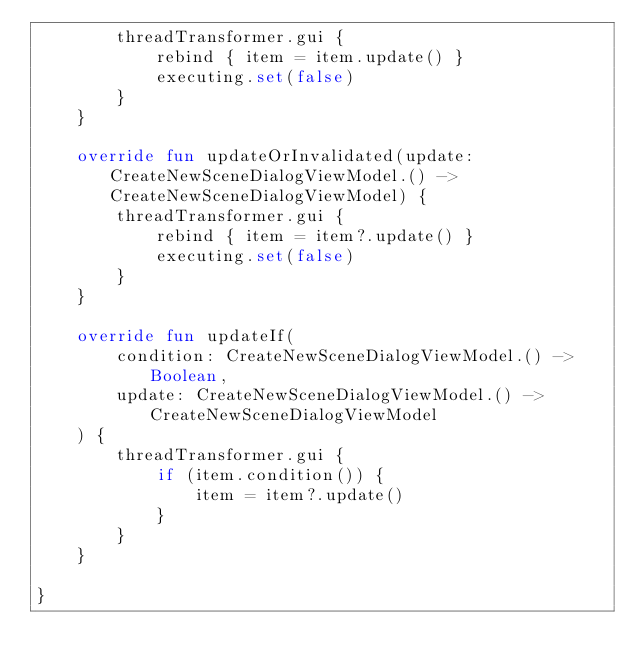<code> <loc_0><loc_0><loc_500><loc_500><_Kotlin_>		threadTransformer.gui {
			rebind { item = item.update() }
			executing.set(false)
		}
	}

	override fun updateOrInvalidated(update: CreateNewSceneDialogViewModel.() -> CreateNewSceneDialogViewModel) {
		threadTransformer.gui {
			rebind { item = item?.update() }
			executing.set(false)
		}
	}

	override fun updateIf(
		condition: CreateNewSceneDialogViewModel.() -> Boolean,
		update: CreateNewSceneDialogViewModel.() -> CreateNewSceneDialogViewModel
	) {
		threadTransformer.gui {
			if (item.condition()) {
				item = item?.update()
			}
		}
	}

}</code> 